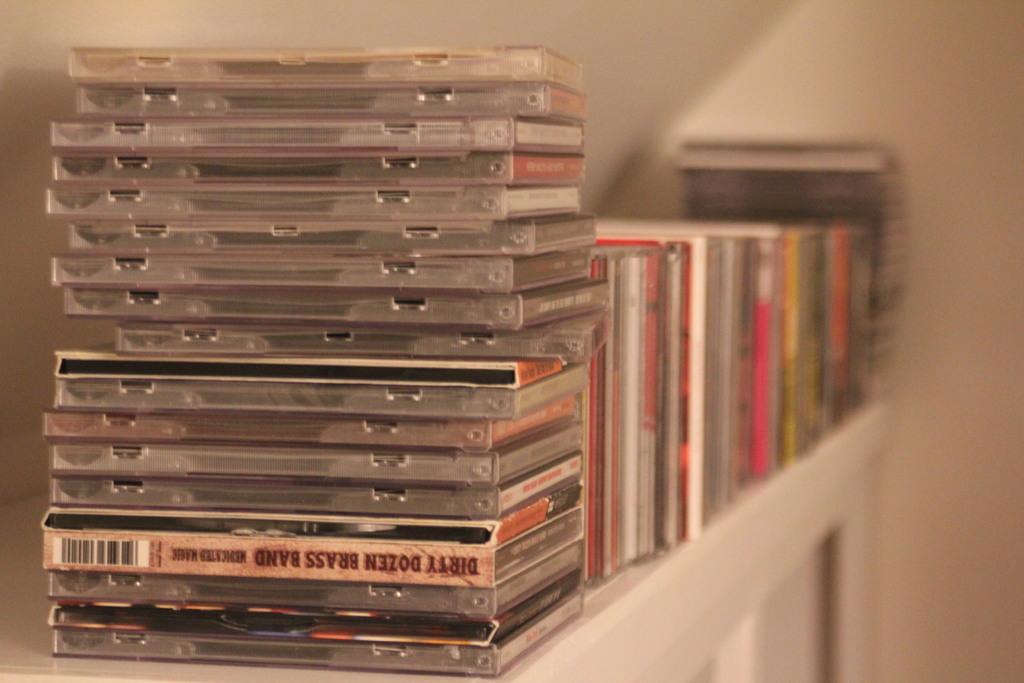What is the name of the cd?
Make the answer very short. Dirty dozen brass band. 